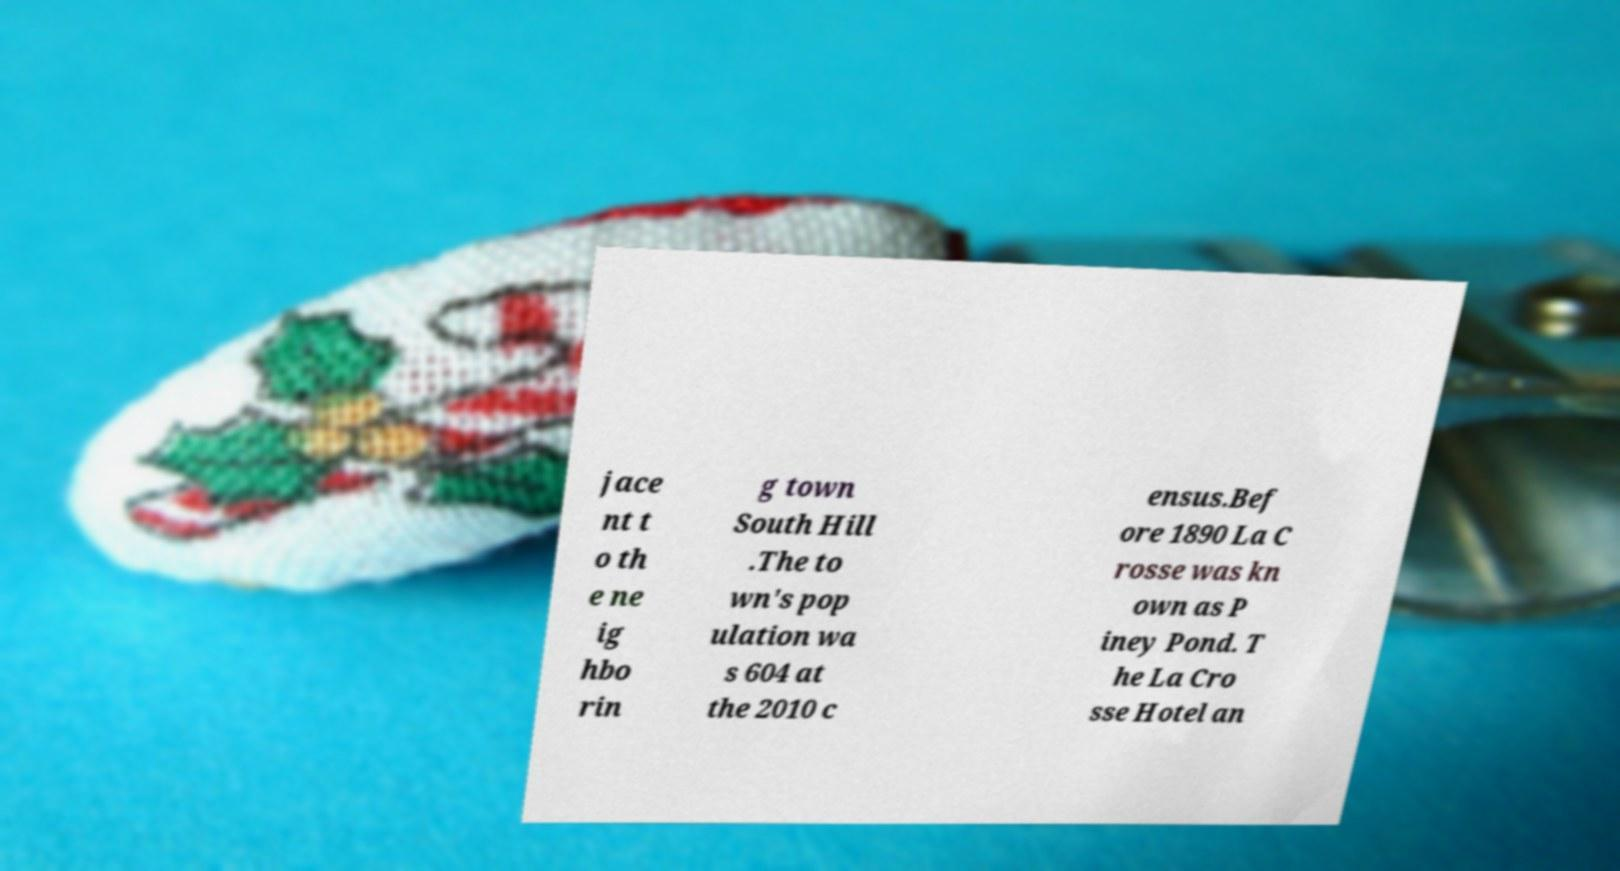There's text embedded in this image that I need extracted. Can you transcribe it verbatim? jace nt t o th e ne ig hbo rin g town South Hill .The to wn's pop ulation wa s 604 at the 2010 c ensus.Bef ore 1890 La C rosse was kn own as P iney Pond. T he La Cro sse Hotel an 